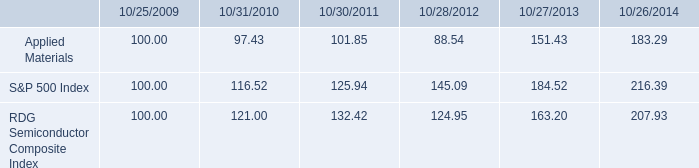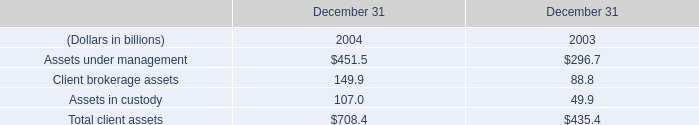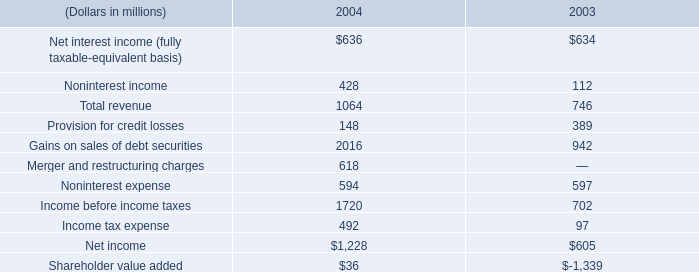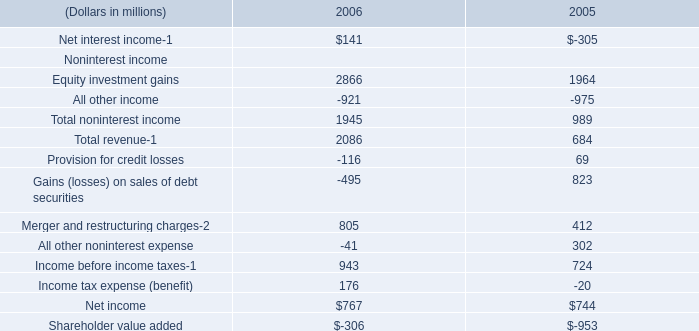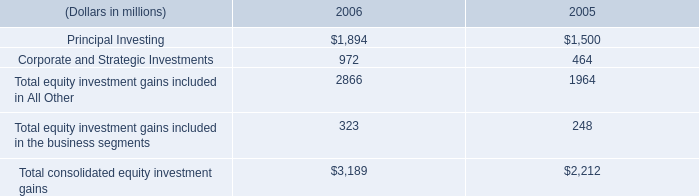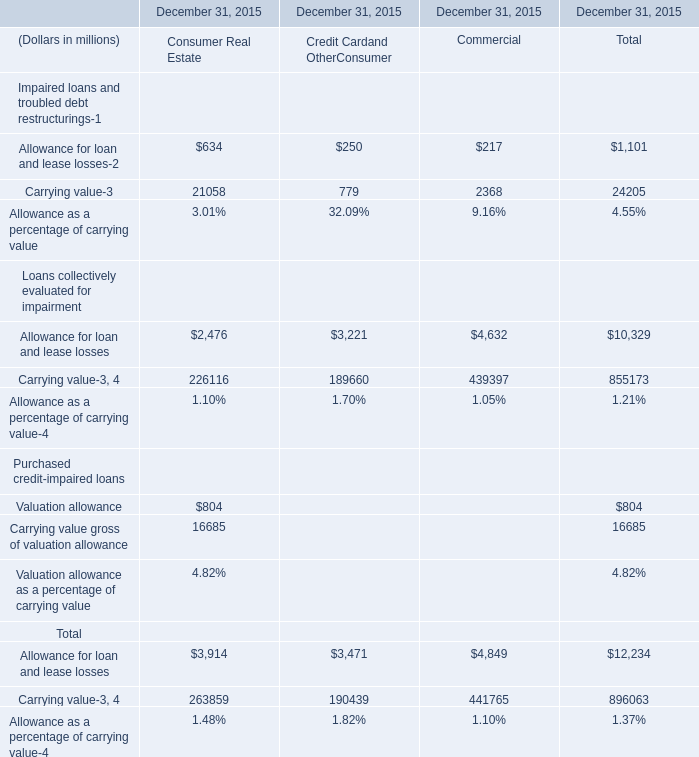What is the total amount of Principal Investing of 2006, Carrying value of December 31, 2015 Commercial, and Carrying value Loans collectively evaluated for impairment of December 31, 2015 Commercial ? 
Computations: ((1894.0 + 2368.0) + 439397.0)
Answer: 443659.0. 